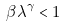Convert formula to latex. <formula><loc_0><loc_0><loc_500><loc_500>\beta \lambda ^ { \gamma } < 1</formula> 